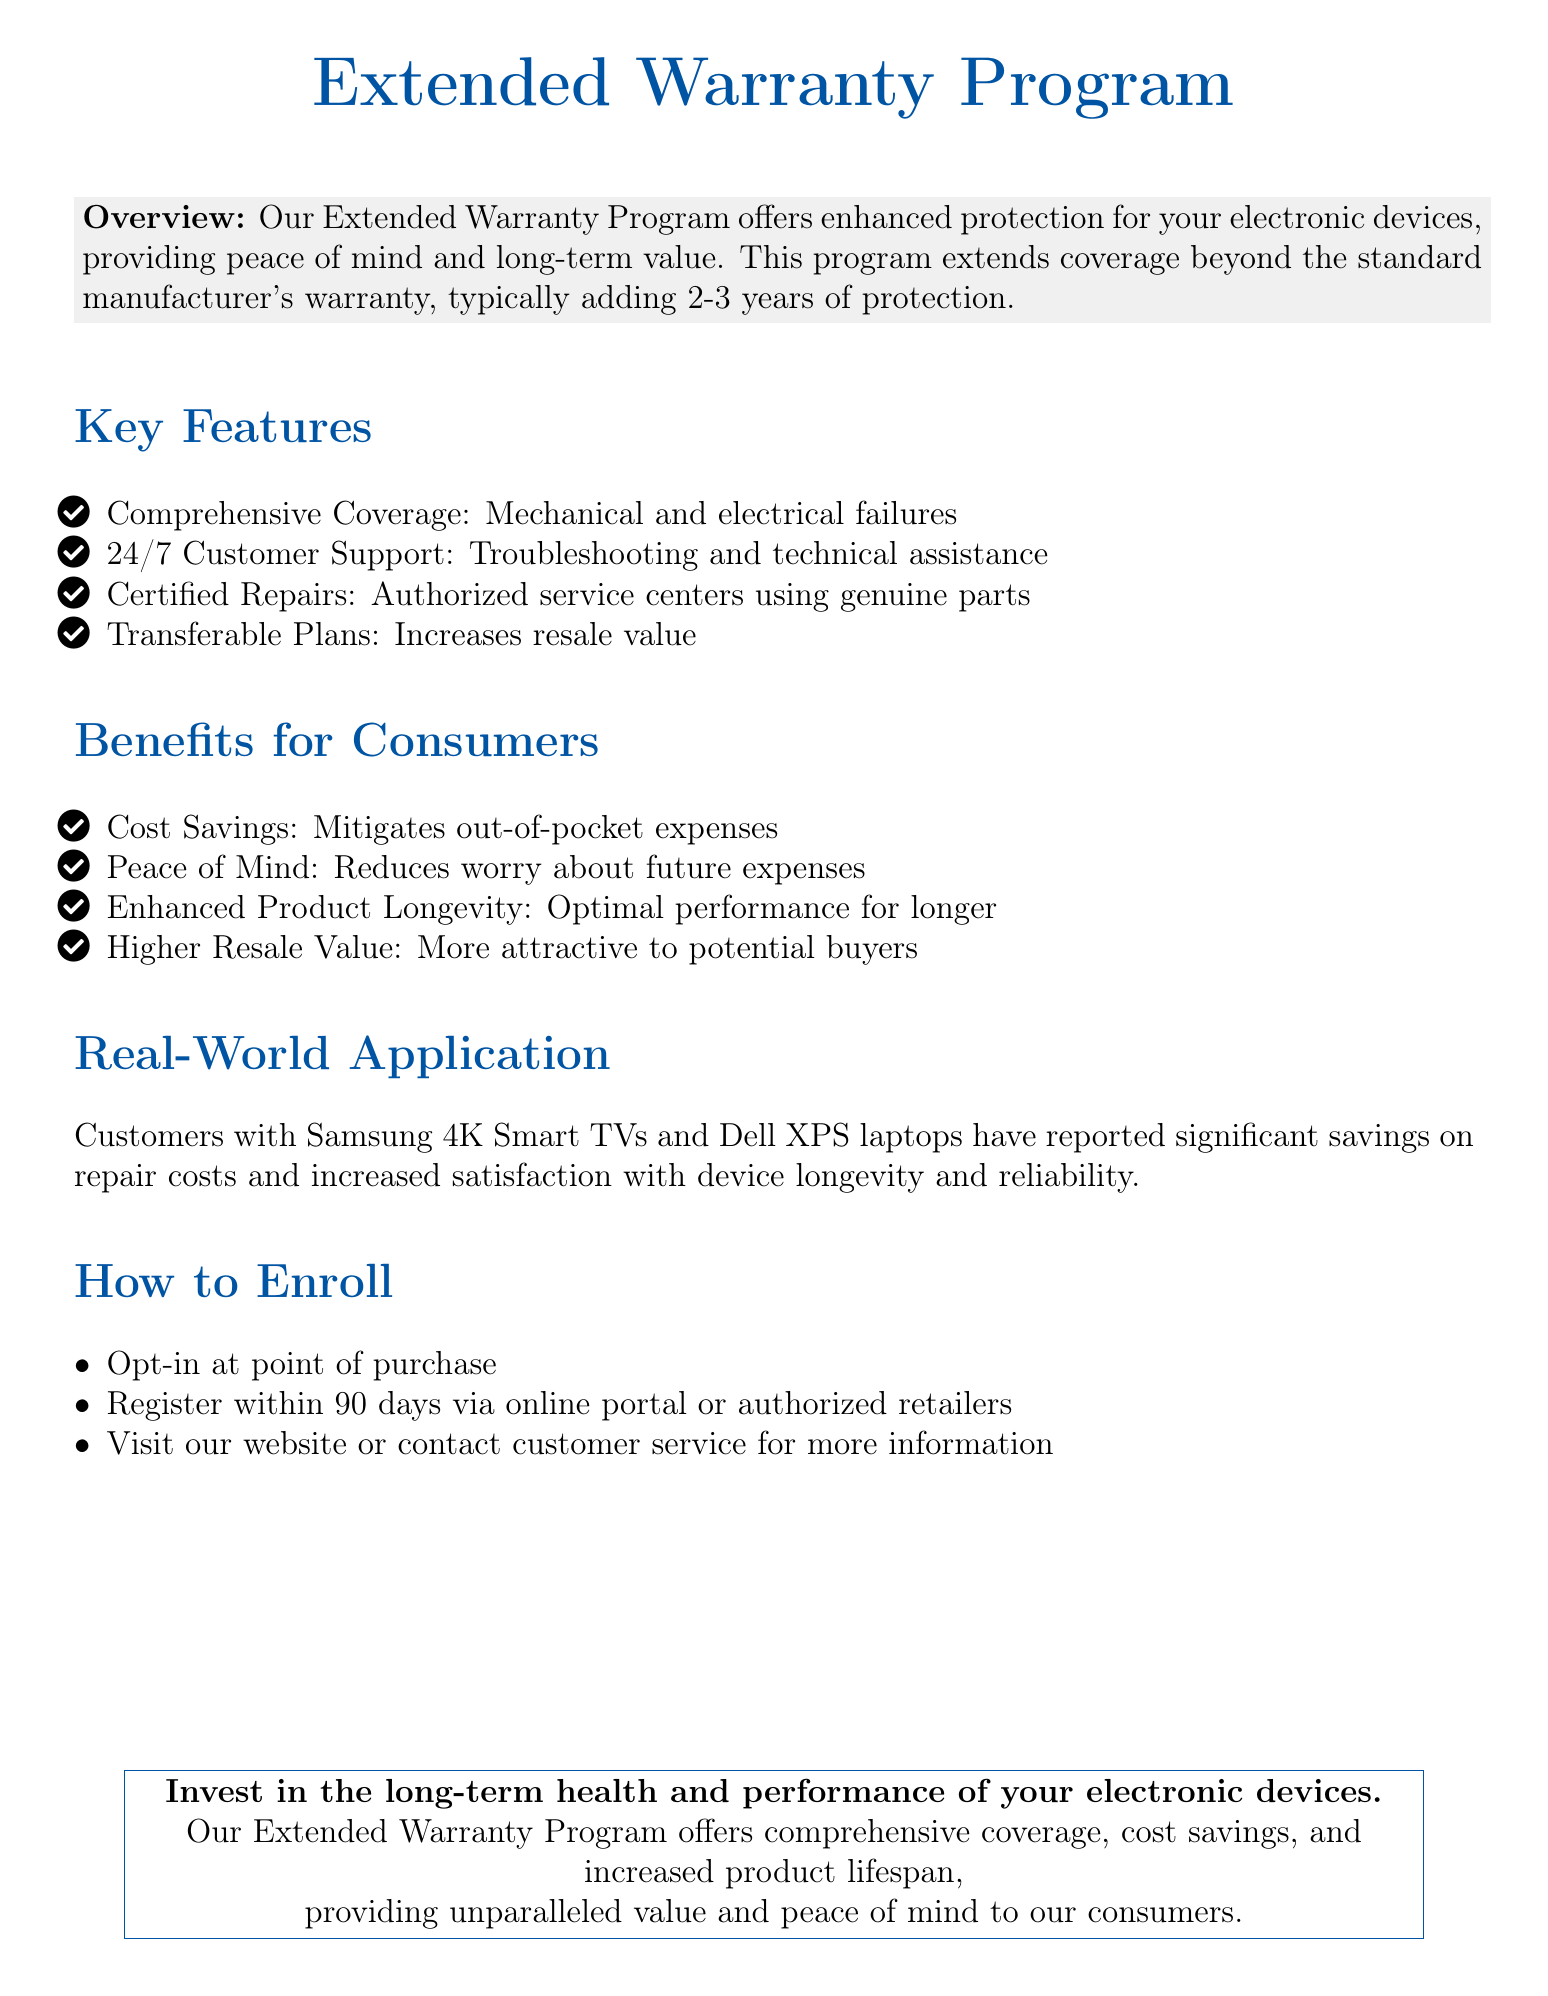What is the duration of the extended coverage? The extended warranty typically adds 2-3 years of protection beyond the standard manufacturer's warranty.
Answer: 2-3 years What type of support is available 24/7? The document states that 24/7 customer support includes troubleshooting and technical assistance for users.
Answer: Troubleshooting and technical assistance What kind of repairs are covered under the program? The program offers certified repairs utilizing genuine parts from authorized service centers for mechanical and electrical failures.
Answer: Certified repairs What are two benefits of the Extended Warranty Program for consumers? The document lists four key benefits, two of which are cost savings and peace of mind.
Answer: Cost savings, peace of mind How can customers enroll in the Extended Warranty Program? Customers can enroll by opting in at the point of purchase and registering within 90 days.
Answer: Opt-in at point of purchase, register within 90 days What products have reported significant savings on repair costs? The document mentions that customers with Samsung 4K Smart TVs and Dell XPS laptops have experienced these benefits.
Answer: Samsung 4K Smart TVs and Dell XPS laptops What is the color scheme used for the document headings? The headings are styled using a corporate blue color, specifically noted in the document.
Answer: Corporate blue How does the Extended Warranty Program affect resale value? The program offers transferable plans that can increase the resale value of devices for consumers.
Answer: Increases resale value 